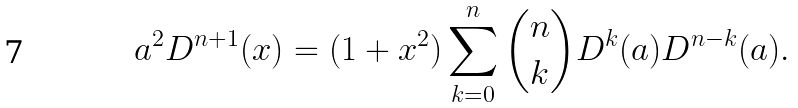<formula> <loc_0><loc_0><loc_500><loc_500>a ^ { 2 } D ^ { n + 1 } ( x ) = ( 1 + x ^ { 2 } ) \sum _ { k = 0 } ^ { n } { n \choose k } D ^ { k } ( a ) D ^ { n - k } ( a ) .</formula> 